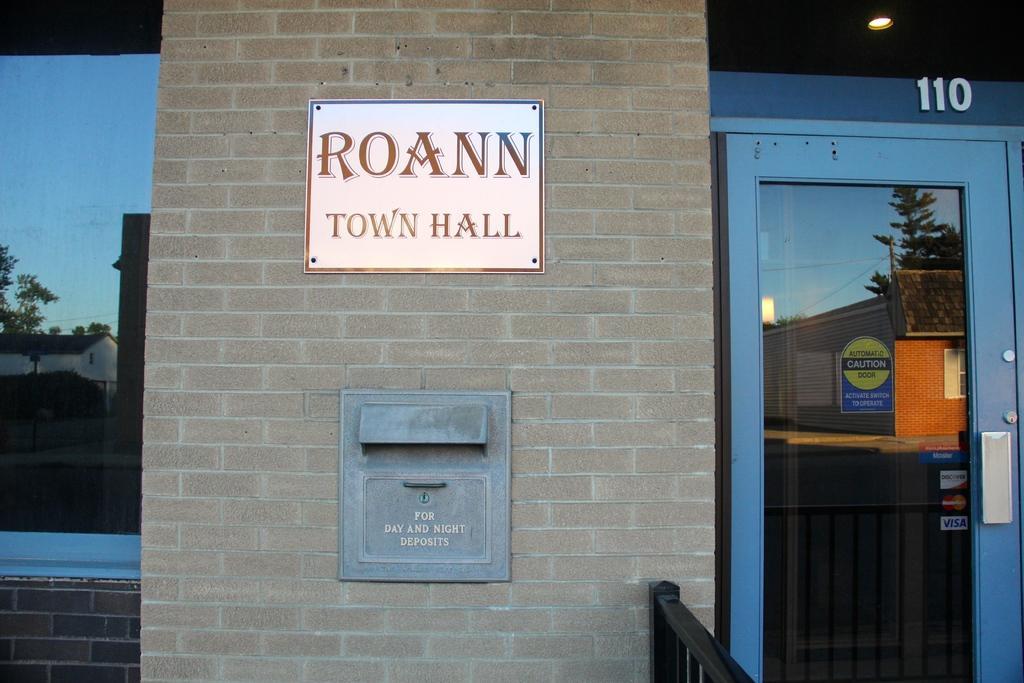Can you describe this image briefly? In the foreground of this image, there is a board and a mail box on the wall. On the left, there is a glass. On the right, there is a glass door. At the top, there is light and few digits. 